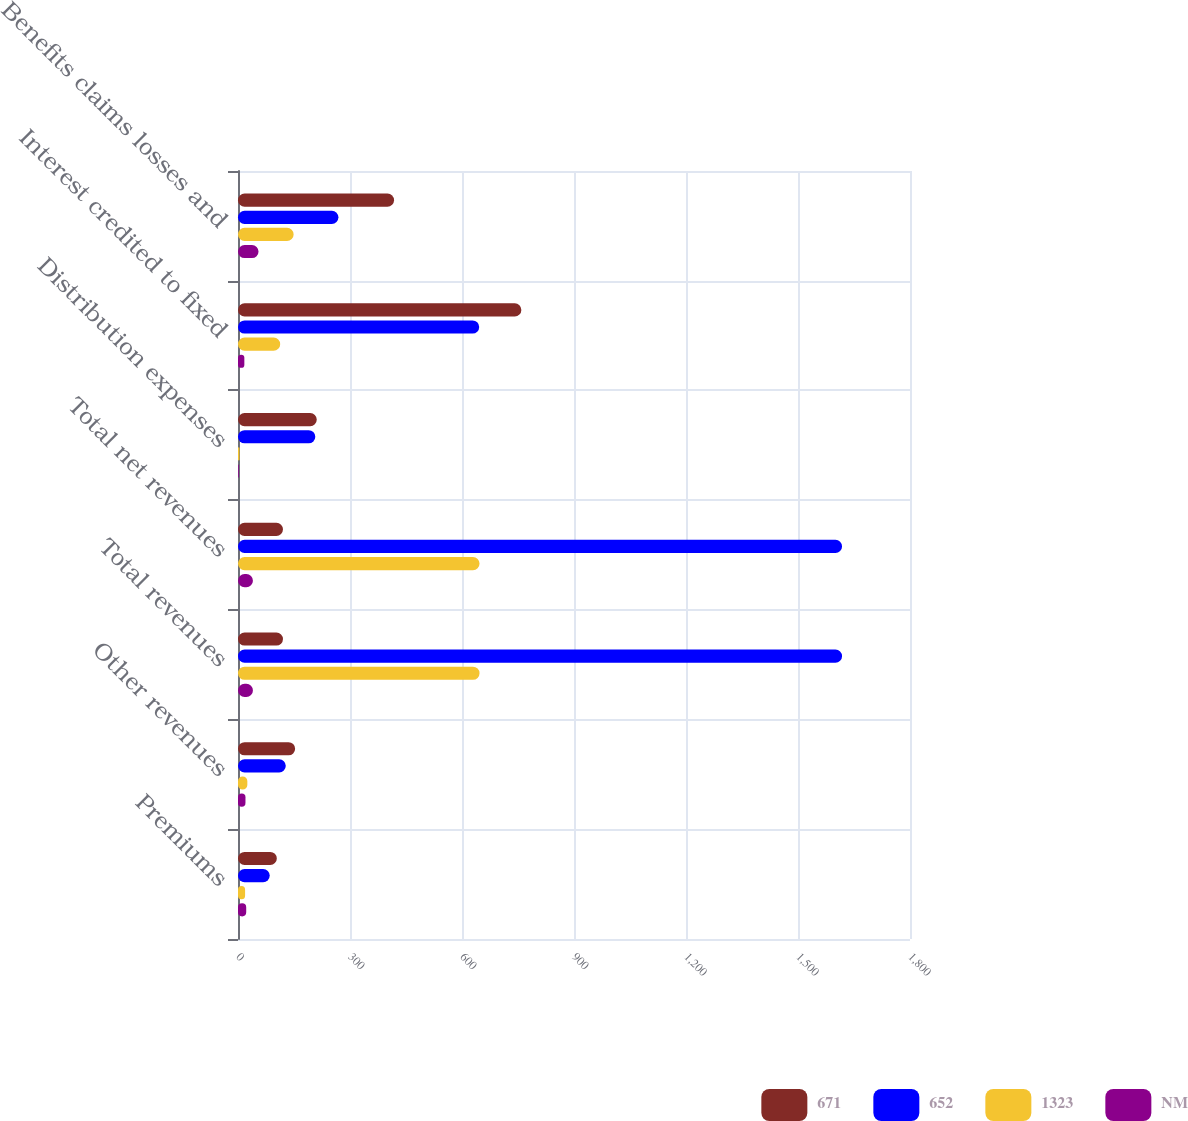Convert chart to OTSL. <chart><loc_0><loc_0><loc_500><loc_500><stacked_bar_chart><ecel><fcel>Premiums<fcel>Other revenues<fcel>Total revenues<fcel>Total net revenues<fcel>Distribution expenses<fcel>Interest credited to fixed<fcel>Benefits claims losses and<nl><fcel>671<fcel>104<fcel>153<fcel>120.5<fcel>120.5<fcel>211<fcel>759<fcel>418<nl><fcel>652<fcel>85<fcel>128<fcel>1618<fcel>1618<fcel>207<fcel>646<fcel>269<nl><fcel>1323<fcel>19<fcel>25<fcel>647<fcel>647<fcel>4<fcel>113<fcel>149<nl><fcel>NM<fcel>22<fcel>20<fcel>40<fcel>40<fcel>2<fcel>17<fcel>55<nl></chart> 